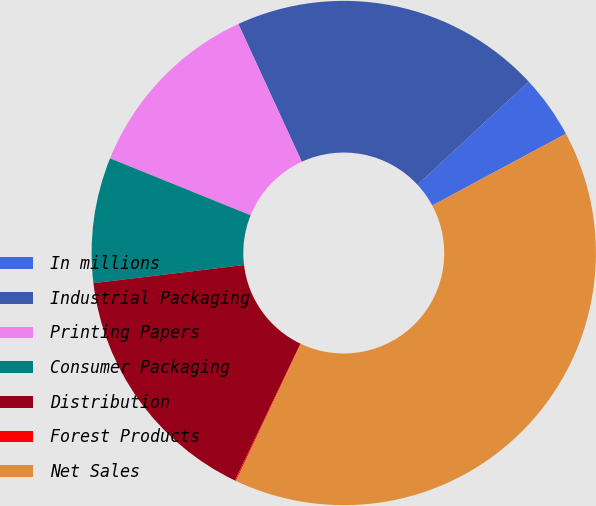Convert chart to OTSL. <chart><loc_0><loc_0><loc_500><loc_500><pie_chart><fcel>In millions<fcel>Industrial Packaging<fcel>Printing Papers<fcel>Consumer Packaging<fcel>Distribution<fcel>Forest Products<fcel>Net Sales<nl><fcel>4.05%<fcel>19.97%<fcel>12.01%<fcel>8.03%<fcel>15.99%<fcel>0.07%<fcel>39.87%<nl></chart> 